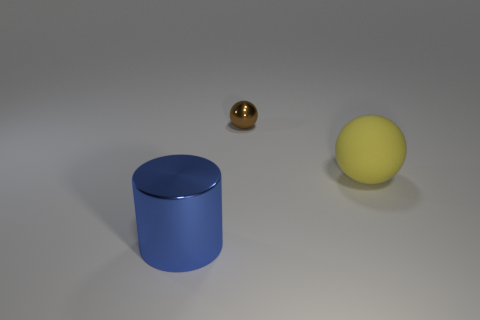Add 1 small brown metal balls. How many objects exist? 4 Subtract all balls. How many objects are left? 1 Subtract all yellow balls. How many balls are left? 1 Subtract 1 spheres. How many spheres are left? 1 Subtract all tiny gray rubber spheres. Subtract all blue metallic cylinders. How many objects are left? 2 Add 1 big yellow matte things. How many big yellow matte things are left? 2 Add 3 big cyan matte objects. How many big cyan matte objects exist? 3 Subtract 0 purple balls. How many objects are left? 3 Subtract all red spheres. Subtract all cyan blocks. How many spheres are left? 2 